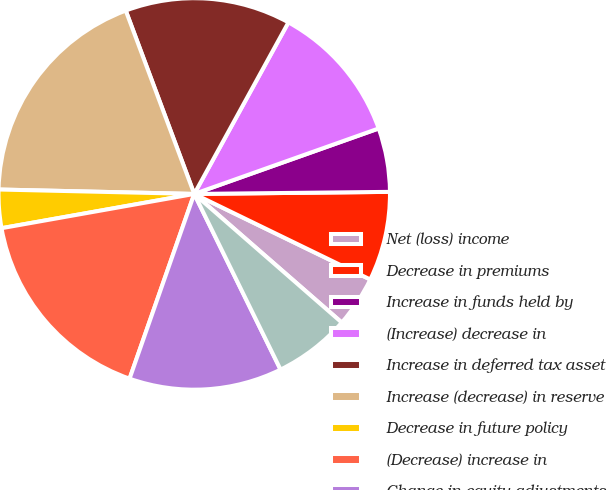<chart> <loc_0><loc_0><loc_500><loc_500><pie_chart><fcel>Net (loss) income<fcel>Decrease in premiums<fcel>Increase in funds held by<fcel>(Increase) decrease in<fcel>Increase in deferred tax asset<fcel>Increase (decrease) in reserve<fcel>Decrease in future policy<fcel>(Decrease) increase in<fcel>Change in equity adjustments<fcel>Change in other assets and<nl><fcel>4.21%<fcel>7.37%<fcel>5.26%<fcel>11.58%<fcel>13.68%<fcel>18.95%<fcel>3.16%<fcel>16.84%<fcel>12.63%<fcel>6.32%<nl></chart> 